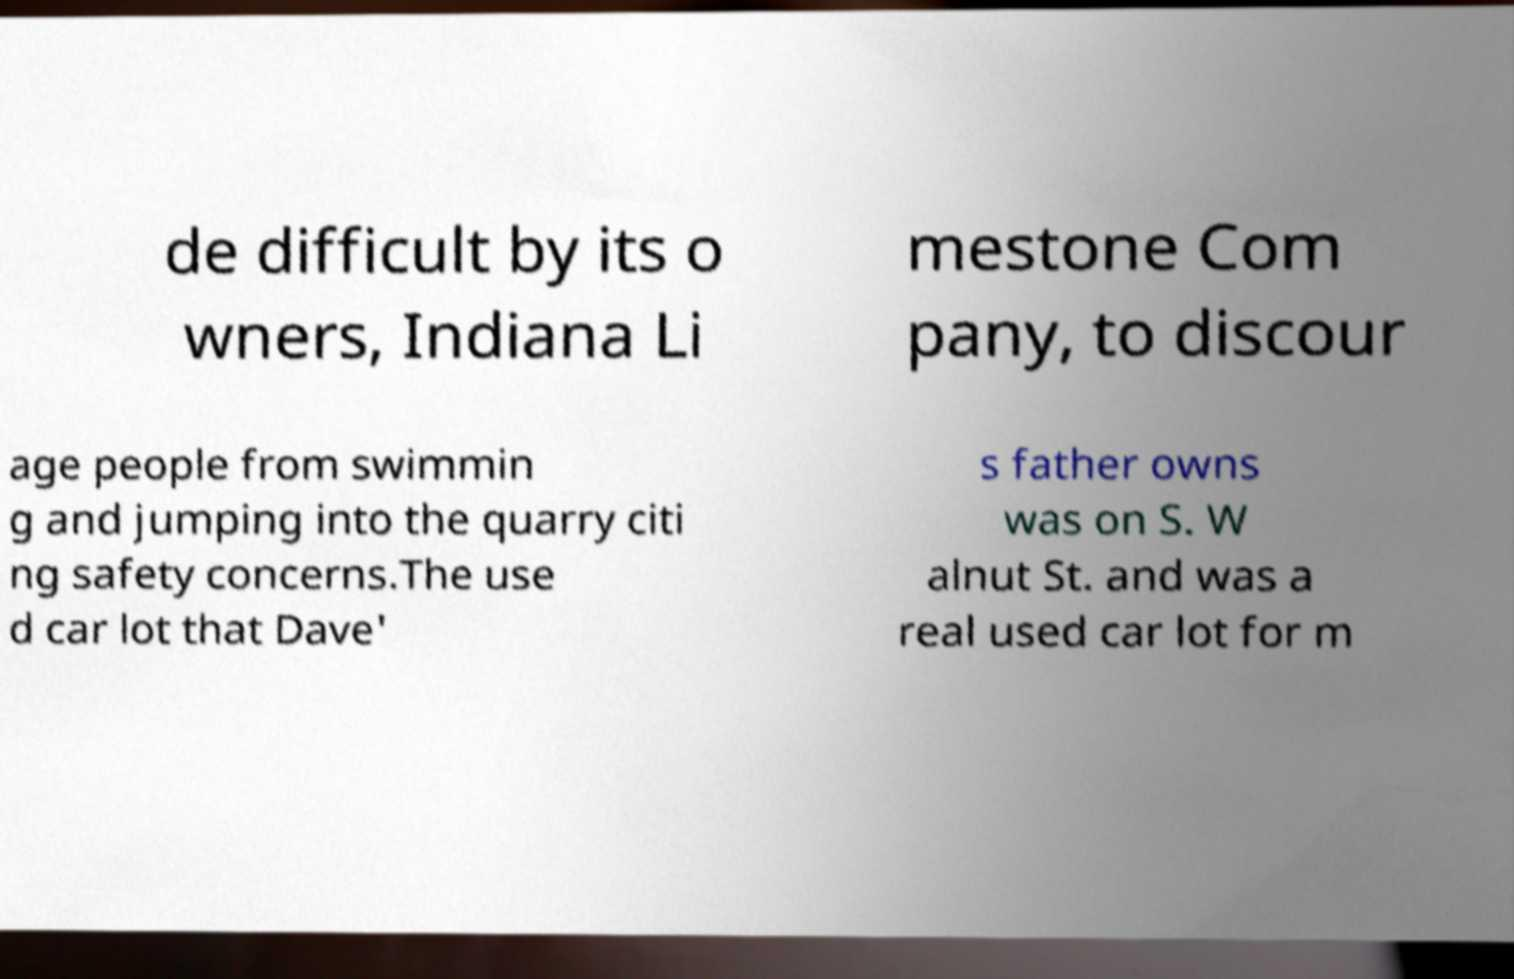Please identify and transcribe the text found in this image. de difficult by its o wners, Indiana Li mestone Com pany, to discour age people from swimmin g and jumping into the quarry citi ng safety concerns.The use d car lot that Dave' s father owns was on S. W alnut St. and was a real used car lot for m 